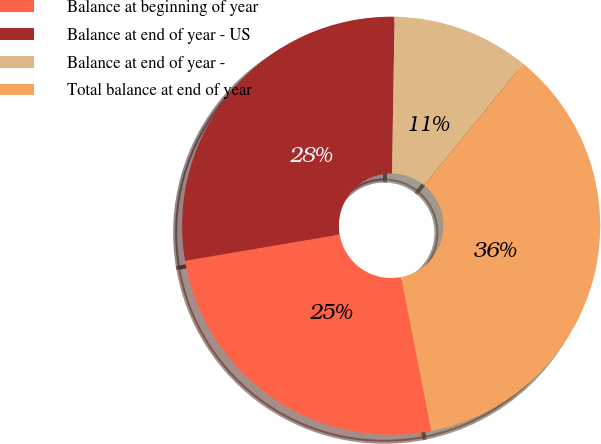Convert chart to OTSL. <chart><loc_0><loc_0><loc_500><loc_500><pie_chart><fcel>Balance at beginning of year<fcel>Balance at end of year - US<fcel>Balance at end of year -<fcel>Total balance at end of year<nl><fcel>25.4%<fcel>27.94%<fcel>10.63%<fcel>36.03%<nl></chart> 